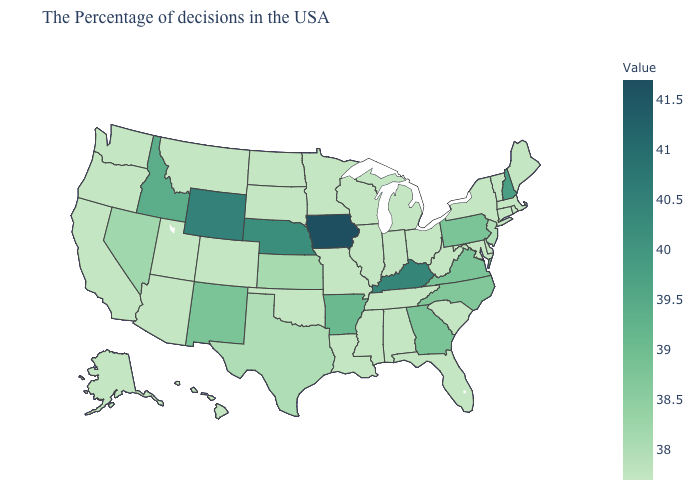Which states have the lowest value in the South?
Keep it brief. Delaware, Maryland, South Carolina, West Virginia, Florida, Alabama, Tennessee, Mississippi, Louisiana, Oklahoma. Which states have the highest value in the USA?
Write a very short answer. Iowa. Does Colorado have the lowest value in the West?
Keep it brief. Yes. Which states have the highest value in the USA?
Be succinct. Iowa. 